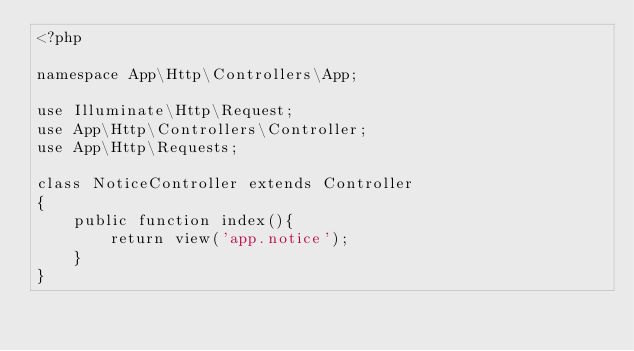<code> <loc_0><loc_0><loc_500><loc_500><_PHP_><?php

namespace App\Http\Controllers\App;

use Illuminate\Http\Request;
use App\Http\Controllers\Controller;
use App\Http\Requests;

class NoticeController extends Controller
{
    public function index(){
        return view('app.notice');
    }
}
</code> 